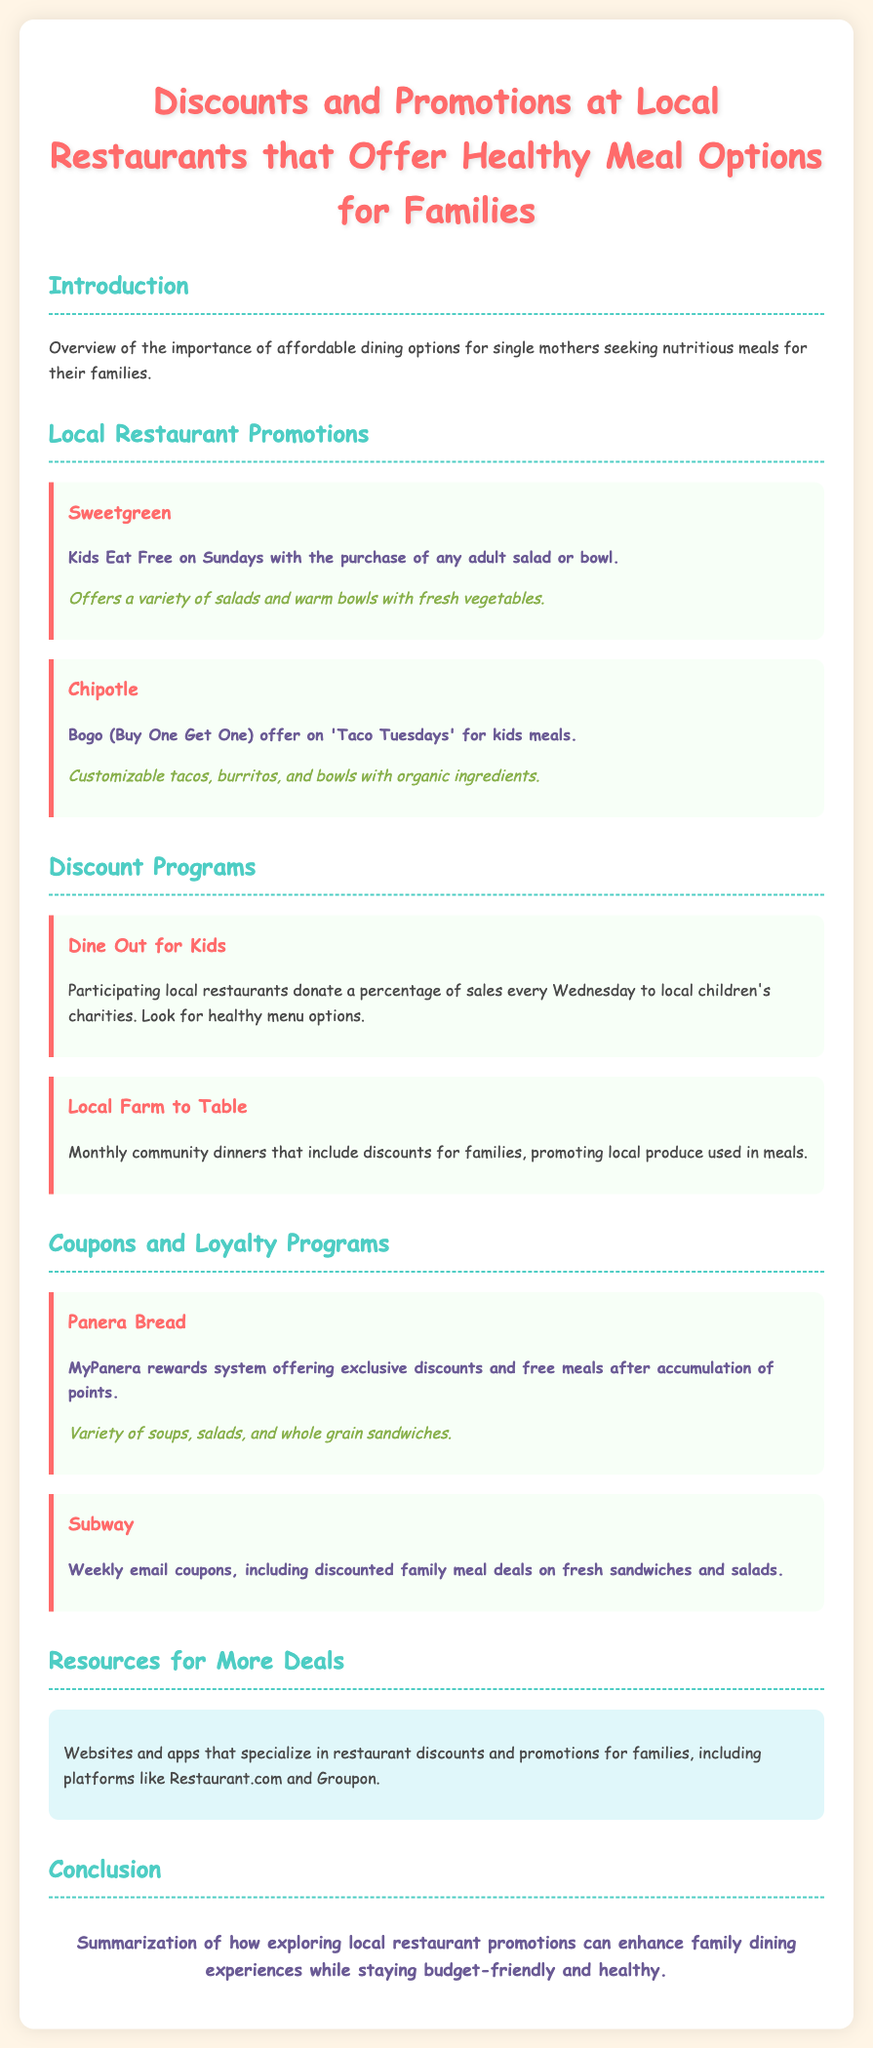What is the promotion at Sweetgreen? Sweetgreen offers a Kids Eat Free promotion on Sundays with the purchase of any adult salad or bowl.
Answer: Kids Eat Free on Sundays What meal options does Chipotle provide on Taco Tuesdays? Chipotle has a Bogo (Buy One Get One) offer on kids meals specifically on Taco Tuesdays.
Answer: Bogo offer on kids meals Which program donates a percentage of sales every Wednesday? "Dine Out for Kids" is the program that donates a percentage of sales every Wednesday to local children's charities.
Answer: Dine Out for Kids What type of meal options does Panera Bread have? Panera Bread offers a variety of soups, salads, and whole grain sandwiches in their healthy meal options.
Answer: Soups, salads, and whole grain sandwiches What does the MyPanera rewards system provide? The MyPanera rewards system provides exclusive discounts and free meals after users accumulate points.
Answer: Exclusive discounts and free meals Which local initiative promotes meals using local produce? Local Farm to Table promotes monthly community dinners that include discounts for families, using local produce.
Answer: Local Farm to Table What type of deals does Subway provide through email? Subway provides weekly email coupons that include discounted family meal deals.
Answer: Discounted family meal deals What kind of websites or apps are mentioned for finding more restaurant deals? Websites and apps for more deals include Restaurant.com and Groupon.
Answer: Restaurant.com and Groupon How is the conclusion summarized in the document? The conclusion summarizes how exploring local restaurant promotions can enhance family dining experiences while staying budget-friendly and healthy.
Answer: Budget-friendly and healthy 